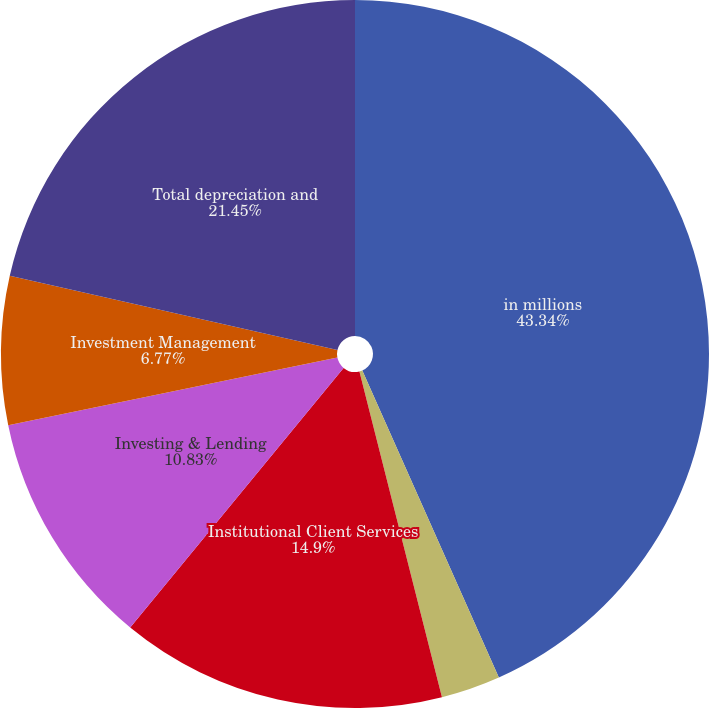Convert chart. <chart><loc_0><loc_0><loc_500><loc_500><pie_chart><fcel>in millions<fcel>Investment Banking<fcel>Institutional Client Services<fcel>Investing & Lending<fcel>Investment Management<fcel>Total depreciation and<nl><fcel>43.34%<fcel>2.71%<fcel>14.9%<fcel>10.83%<fcel>6.77%<fcel>21.45%<nl></chart> 